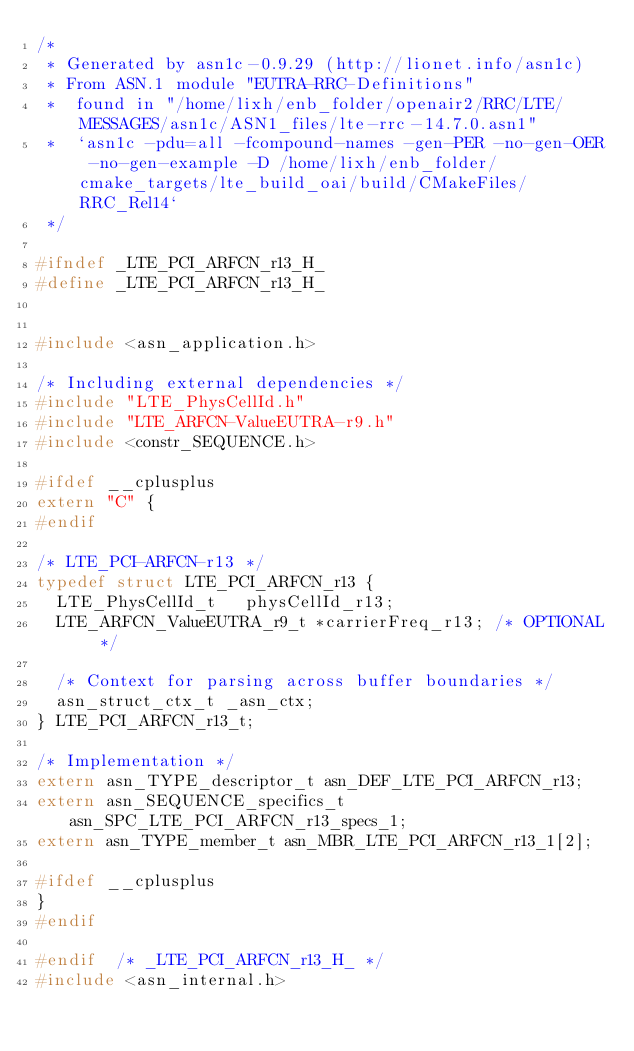<code> <loc_0><loc_0><loc_500><loc_500><_C_>/*
 * Generated by asn1c-0.9.29 (http://lionet.info/asn1c)
 * From ASN.1 module "EUTRA-RRC-Definitions"
 * 	found in "/home/lixh/enb_folder/openair2/RRC/LTE/MESSAGES/asn1c/ASN1_files/lte-rrc-14.7.0.asn1"
 * 	`asn1c -pdu=all -fcompound-names -gen-PER -no-gen-OER -no-gen-example -D /home/lixh/enb_folder/cmake_targets/lte_build_oai/build/CMakeFiles/RRC_Rel14`
 */

#ifndef	_LTE_PCI_ARFCN_r13_H_
#define	_LTE_PCI_ARFCN_r13_H_


#include <asn_application.h>

/* Including external dependencies */
#include "LTE_PhysCellId.h"
#include "LTE_ARFCN-ValueEUTRA-r9.h"
#include <constr_SEQUENCE.h>

#ifdef __cplusplus
extern "C" {
#endif

/* LTE_PCI-ARFCN-r13 */
typedef struct LTE_PCI_ARFCN_r13 {
	LTE_PhysCellId_t	 physCellId_r13;
	LTE_ARFCN_ValueEUTRA_r9_t	*carrierFreq_r13;	/* OPTIONAL */
	
	/* Context for parsing across buffer boundaries */
	asn_struct_ctx_t _asn_ctx;
} LTE_PCI_ARFCN_r13_t;

/* Implementation */
extern asn_TYPE_descriptor_t asn_DEF_LTE_PCI_ARFCN_r13;
extern asn_SEQUENCE_specifics_t asn_SPC_LTE_PCI_ARFCN_r13_specs_1;
extern asn_TYPE_member_t asn_MBR_LTE_PCI_ARFCN_r13_1[2];

#ifdef __cplusplus
}
#endif

#endif	/* _LTE_PCI_ARFCN_r13_H_ */
#include <asn_internal.h>
</code> 